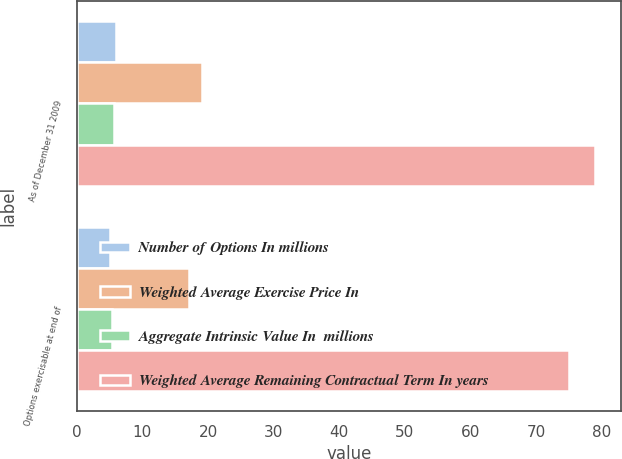Convert chart. <chart><loc_0><loc_0><loc_500><loc_500><stacked_bar_chart><ecel><fcel>As of December 31 2009<fcel>Options exercisable at end of<nl><fcel>Number of Options In millions<fcel>6<fcel>5<nl><fcel>Weighted Average Exercise Price In<fcel>19.01<fcel>17.09<nl><fcel>Aggregate Intrinsic Value In  millions<fcel>5.6<fcel>5.3<nl><fcel>Weighted Average Remaining Contractual Term In years<fcel>79<fcel>75<nl></chart> 